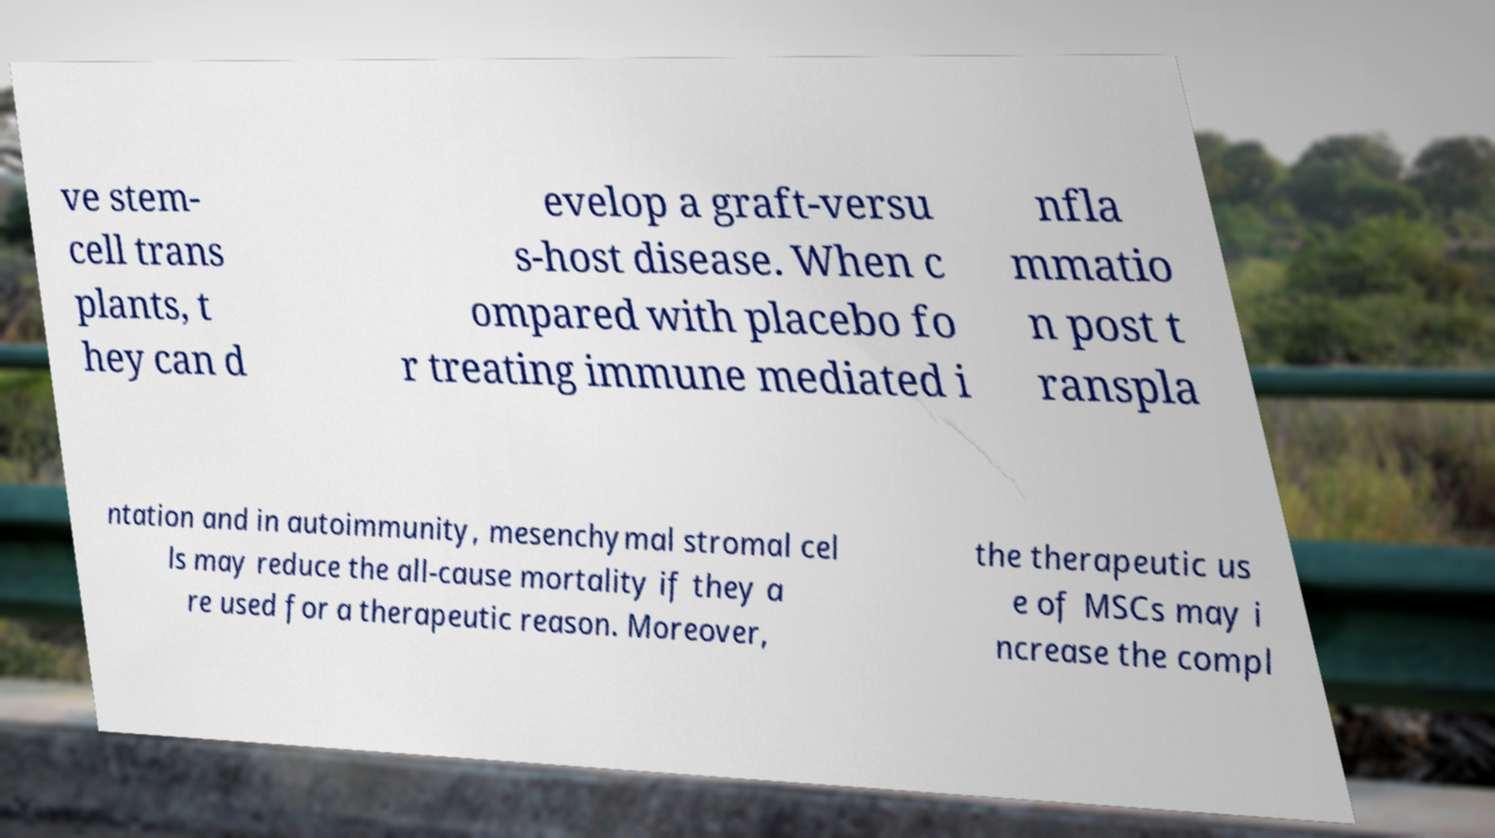For documentation purposes, I need the text within this image transcribed. Could you provide that? ve stem- cell trans plants, t hey can d evelop a graft-versu s-host disease. When c ompared with placebo fo r treating immune mediated i nfla mmatio n post t ranspla ntation and in autoimmunity, mesenchymal stromal cel ls may reduce the all-cause mortality if they a re used for a therapeutic reason. Moreover, the therapeutic us e of MSCs may i ncrease the compl 